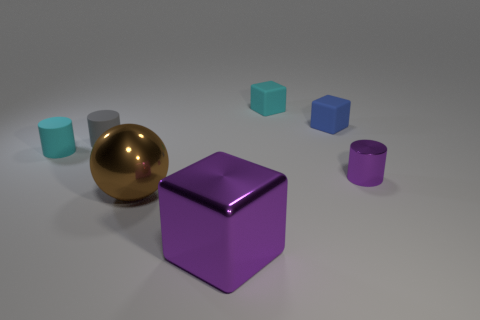There is a purple cube that is the same size as the sphere; what material is it?
Your answer should be very brief. Metal. How many big objects are either red matte things or metallic cylinders?
Provide a short and direct response. 0. Are any large yellow metal cubes visible?
Provide a short and direct response. No. What is the size of the cube that is the same material as the blue object?
Make the answer very short. Small. Does the tiny purple object have the same material as the gray object?
Provide a short and direct response. No. What number of other things are the same material as the blue object?
Give a very brief answer. 3. How many tiny cylinders are both left of the small blue matte block and to the right of the gray matte thing?
Your answer should be very brief. 0. The small shiny thing has what color?
Offer a terse response. Purple. There is a purple thing that is the same shape as the tiny gray matte object; what is it made of?
Provide a short and direct response. Metal. Are there any other things that have the same material as the tiny blue object?
Your answer should be compact. Yes. 